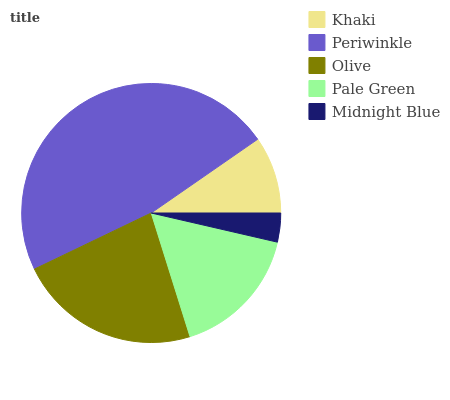Is Midnight Blue the minimum?
Answer yes or no. Yes. Is Periwinkle the maximum?
Answer yes or no. Yes. Is Olive the minimum?
Answer yes or no. No. Is Olive the maximum?
Answer yes or no. No. Is Periwinkle greater than Olive?
Answer yes or no. Yes. Is Olive less than Periwinkle?
Answer yes or no. Yes. Is Olive greater than Periwinkle?
Answer yes or no. No. Is Periwinkle less than Olive?
Answer yes or no. No. Is Pale Green the high median?
Answer yes or no. Yes. Is Pale Green the low median?
Answer yes or no. Yes. Is Midnight Blue the high median?
Answer yes or no. No. Is Olive the low median?
Answer yes or no. No. 